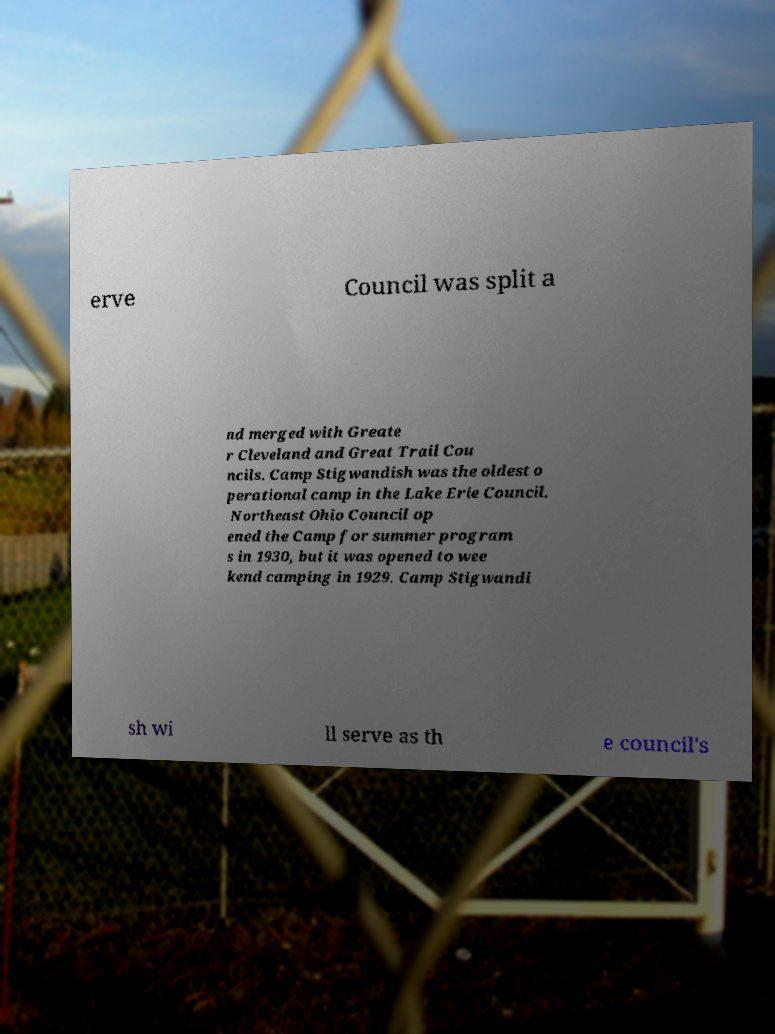Could you extract and type out the text from this image? erve Council was split a nd merged with Greate r Cleveland and Great Trail Cou ncils. Camp Stigwandish was the oldest o perational camp in the Lake Erie Council. Northeast Ohio Council op ened the Camp for summer program s in 1930, but it was opened to wee kend camping in 1929. Camp Stigwandi sh wi ll serve as th e council's 